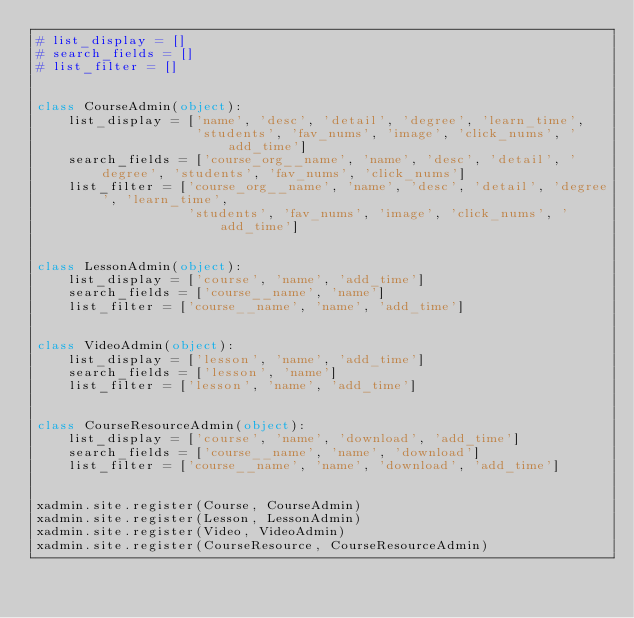<code> <loc_0><loc_0><loc_500><loc_500><_Python_># list_display = []
# search_fields = []
# list_filter = []


class CourseAdmin(object):
    list_display = ['name', 'desc', 'detail', 'degree', 'learn_time',
                    'students', 'fav_nums', 'image', 'click_nums', 'add_time']
    search_fields = ['course_org__name', 'name', 'desc', 'detail', 'degree', 'students', 'fav_nums', 'click_nums']
    list_filter = ['course_org__name', 'name', 'desc', 'detail', 'degree', 'learn_time',
                   'students', 'fav_nums', 'image', 'click_nums', 'add_time']


class LessonAdmin(object):
    list_display = ['course', 'name', 'add_time']
    search_fields = ['course__name', 'name']
    list_filter = ['course__name', 'name', 'add_time']


class VideoAdmin(object):
    list_display = ['lesson', 'name', 'add_time']
    search_fields = ['lesson', 'name']
    list_filter = ['lesson', 'name', 'add_time']


class CourseResourceAdmin(object):
    list_display = ['course', 'name', 'download', 'add_time']
    search_fields = ['course__name', 'name', 'download']
    list_filter = ['course__name', 'name', 'download', 'add_time']


xadmin.site.register(Course, CourseAdmin)
xadmin.site.register(Lesson, LessonAdmin)
xadmin.site.register(Video, VideoAdmin)
xadmin.site.register(CourseResource, CourseResourceAdmin)
</code> 